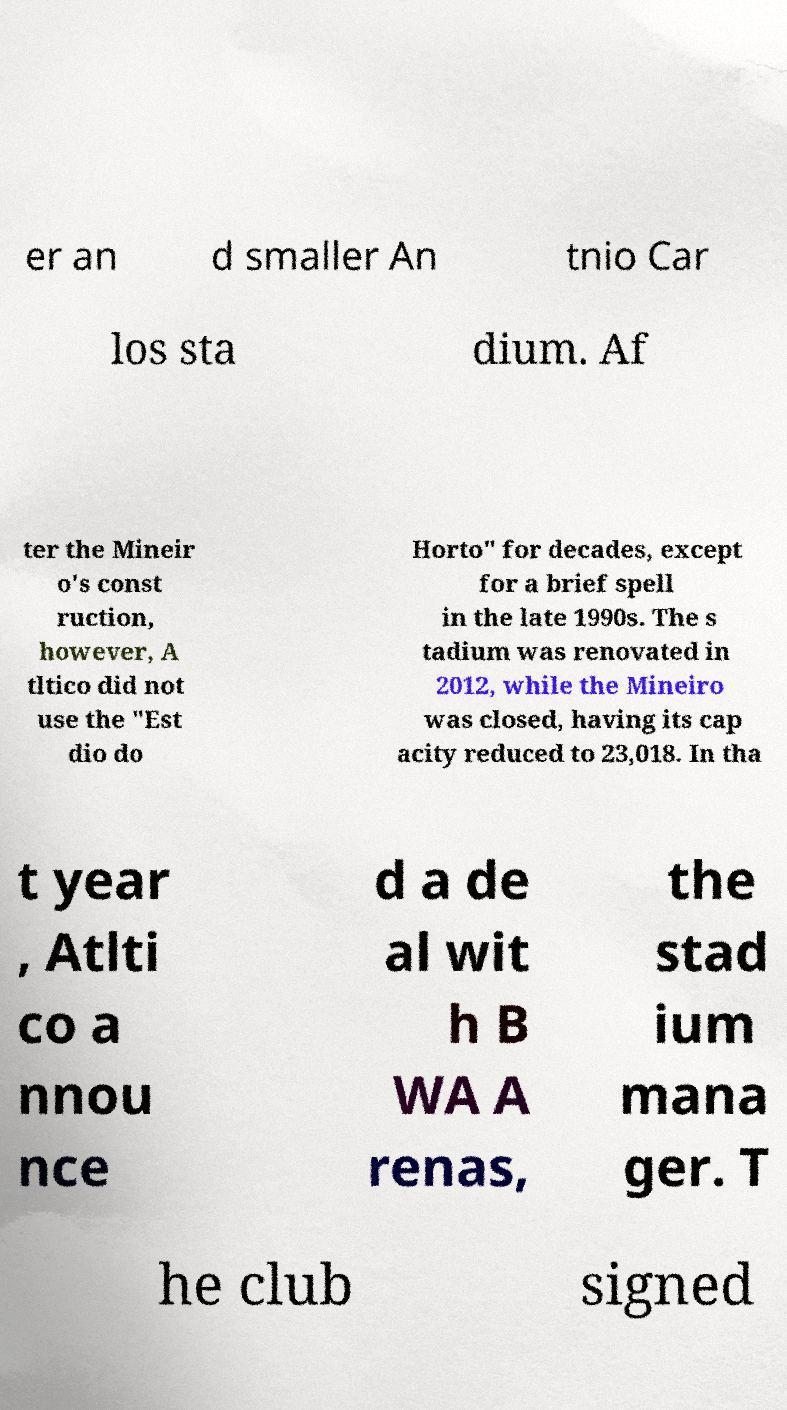For documentation purposes, I need the text within this image transcribed. Could you provide that? er an d smaller An tnio Car los sta dium. Af ter the Mineir o's const ruction, however, A tltico did not use the "Est dio do Horto" for decades, except for a brief spell in the late 1990s. The s tadium was renovated in 2012, while the Mineiro was closed, having its cap acity reduced to 23,018. In tha t year , Atlti co a nnou nce d a de al wit h B WA A renas, the stad ium mana ger. T he club signed 